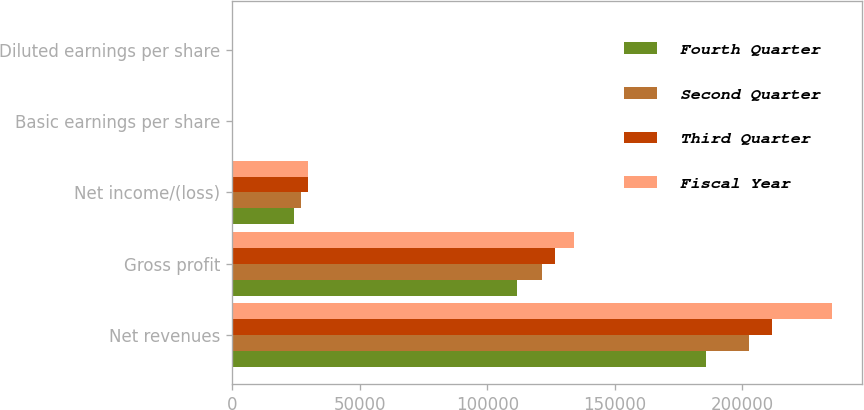Convert chart. <chart><loc_0><loc_0><loc_500><loc_500><stacked_bar_chart><ecel><fcel>Net revenues<fcel>Gross profit<fcel>Net income/(loss)<fcel>Basic earnings per share<fcel>Diluted earnings per share<nl><fcel>Fourth Quarter<fcel>185740<fcel>111777<fcel>24125<fcel>0.31<fcel>0.3<nl><fcel>Second Quarter<fcel>202679<fcel>121331<fcel>26861<fcel>0.35<fcel>0.34<nl><fcel>Third Quarter<fcel>211827<fcel>126558<fcel>29684<fcel>0.38<fcel>0.38<nl><fcel>Fiscal Year<fcel>235151<fcel>134084<fcel>29633<fcel>0.38<fcel>0.38<nl></chart> 